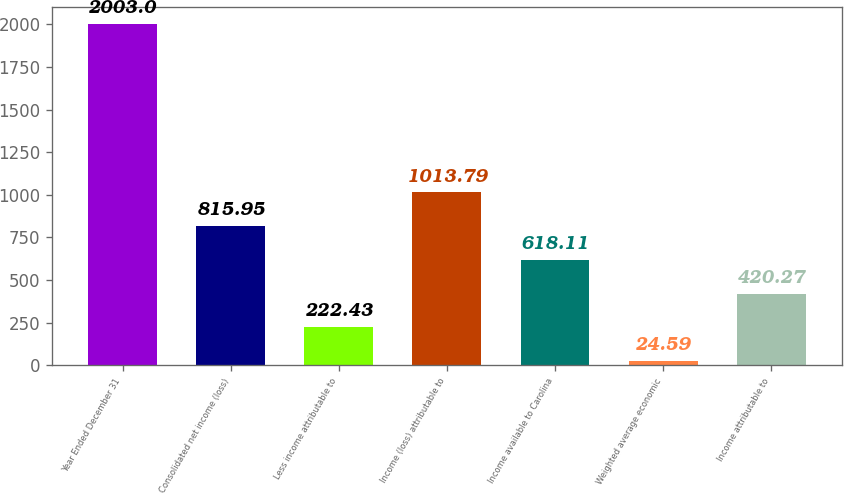<chart> <loc_0><loc_0><loc_500><loc_500><bar_chart><fcel>Year Ended December 31<fcel>Consolidated net income (loss)<fcel>Less income attributable to<fcel>Income (loss) attributable to<fcel>Income available to Carolina<fcel>Weighted average economic<fcel>Income attributable to<nl><fcel>2003<fcel>815.95<fcel>222.43<fcel>1013.79<fcel>618.11<fcel>24.59<fcel>420.27<nl></chart> 